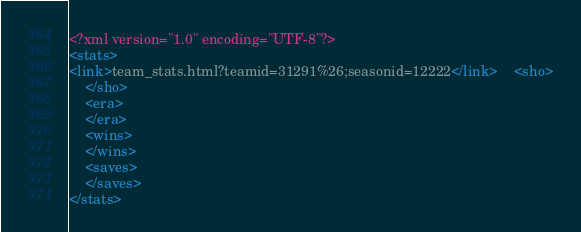<code> <loc_0><loc_0><loc_500><loc_500><_XML_><?xml version="1.0" encoding="UTF-8"?>
<stats>
<link>team_stats.html?teamid=31291%26;seasonid=12222</link>	<sho>
	</sho>
	<era>
	</era>
	<wins>
	</wins>
	<saves>
	</saves>
</stats>
</code> 